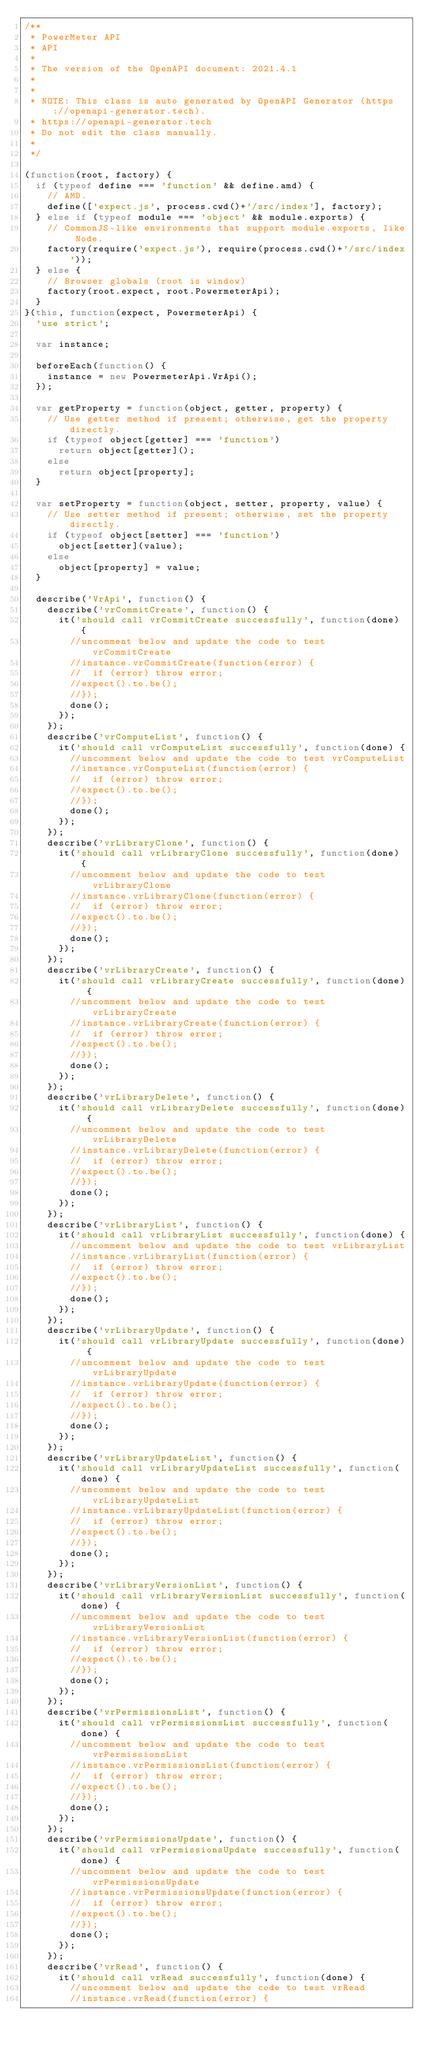<code> <loc_0><loc_0><loc_500><loc_500><_JavaScript_>/**
 * PowerMeter API
 * API
 *
 * The version of the OpenAPI document: 2021.4.1
 * 
 *
 * NOTE: This class is auto generated by OpenAPI Generator (https://openapi-generator.tech).
 * https://openapi-generator.tech
 * Do not edit the class manually.
 *
 */

(function(root, factory) {
  if (typeof define === 'function' && define.amd) {
    // AMD.
    define(['expect.js', process.cwd()+'/src/index'], factory);
  } else if (typeof module === 'object' && module.exports) {
    // CommonJS-like environments that support module.exports, like Node.
    factory(require('expect.js'), require(process.cwd()+'/src/index'));
  } else {
    // Browser globals (root is window)
    factory(root.expect, root.PowermeterApi);
  }
}(this, function(expect, PowermeterApi) {
  'use strict';

  var instance;

  beforeEach(function() {
    instance = new PowermeterApi.VrApi();
  });

  var getProperty = function(object, getter, property) {
    // Use getter method if present; otherwise, get the property directly.
    if (typeof object[getter] === 'function')
      return object[getter]();
    else
      return object[property];
  }

  var setProperty = function(object, setter, property, value) {
    // Use setter method if present; otherwise, set the property directly.
    if (typeof object[setter] === 'function')
      object[setter](value);
    else
      object[property] = value;
  }

  describe('VrApi', function() {
    describe('vrCommitCreate', function() {
      it('should call vrCommitCreate successfully', function(done) {
        //uncomment below and update the code to test vrCommitCreate
        //instance.vrCommitCreate(function(error) {
        //  if (error) throw error;
        //expect().to.be();
        //});
        done();
      });
    });
    describe('vrComputeList', function() {
      it('should call vrComputeList successfully', function(done) {
        //uncomment below and update the code to test vrComputeList
        //instance.vrComputeList(function(error) {
        //  if (error) throw error;
        //expect().to.be();
        //});
        done();
      });
    });
    describe('vrLibraryClone', function() {
      it('should call vrLibraryClone successfully', function(done) {
        //uncomment below and update the code to test vrLibraryClone
        //instance.vrLibraryClone(function(error) {
        //  if (error) throw error;
        //expect().to.be();
        //});
        done();
      });
    });
    describe('vrLibraryCreate', function() {
      it('should call vrLibraryCreate successfully', function(done) {
        //uncomment below and update the code to test vrLibraryCreate
        //instance.vrLibraryCreate(function(error) {
        //  if (error) throw error;
        //expect().to.be();
        //});
        done();
      });
    });
    describe('vrLibraryDelete', function() {
      it('should call vrLibraryDelete successfully', function(done) {
        //uncomment below and update the code to test vrLibraryDelete
        //instance.vrLibraryDelete(function(error) {
        //  if (error) throw error;
        //expect().to.be();
        //});
        done();
      });
    });
    describe('vrLibraryList', function() {
      it('should call vrLibraryList successfully', function(done) {
        //uncomment below and update the code to test vrLibraryList
        //instance.vrLibraryList(function(error) {
        //  if (error) throw error;
        //expect().to.be();
        //});
        done();
      });
    });
    describe('vrLibraryUpdate', function() {
      it('should call vrLibraryUpdate successfully', function(done) {
        //uncomment below and update the code to test vrLibraryUpdate
        //instance.vrLibraryUpdate(function(error) {
        //  if (error) throw error;
        //expect().to.be();
        //});
        done();
      });
    });
    describe('vrLibraryUpdateList', function() {
      it('should call vrLibraryUpdateList successfully', function(done) {
        //uncomment below and update the code to test vrLibraryUpdateList
        //instance.vrLibraryUpdateList(function(error) {
        //  if (error) throw error;
        //expect().to.be();
        //});
        done();
      });
    });
    describe('vrLibraryVersionList', function() {
      it('should call vrLibraryVersionList successfully', function(done) {
        //uncomment below and update the code to test vrLibraryVersionList
        //instance.vrLibraryVersionList(function(error) {
        //  if (error) throw error;
        //expect().to.be();
        //});
        done();
      });
    });
    describe('vrPermissionsList', function() {
      it('should call vrPermissionsList successfully', function(done) {
        //uncomment below and update the code to test vrPermissionsList
        //instance.vrPermissionsList(function(error) {
        //  if (error) throw error;
        //expect().to.be();
        //});
        done();
      });
    });
    describe('vrPermissionsUpdate', function() {
      it('should call vrPermissionsUpdate successfully', function(done) {
        //uncomment below and update the code to test vrPermissionsUpdate
        //instance.vrPermissionsUpdate(function(error) {
        //  if (error) throw error;
        //expect().to.be();
        //});
        done();
      });
    });
    describe('vrRead', function() {
      it('should call vrRead successfully', function(done) {
        //uncomment below and update the code to test vrRead
        //instance.vrRead(function(error) {</code> 